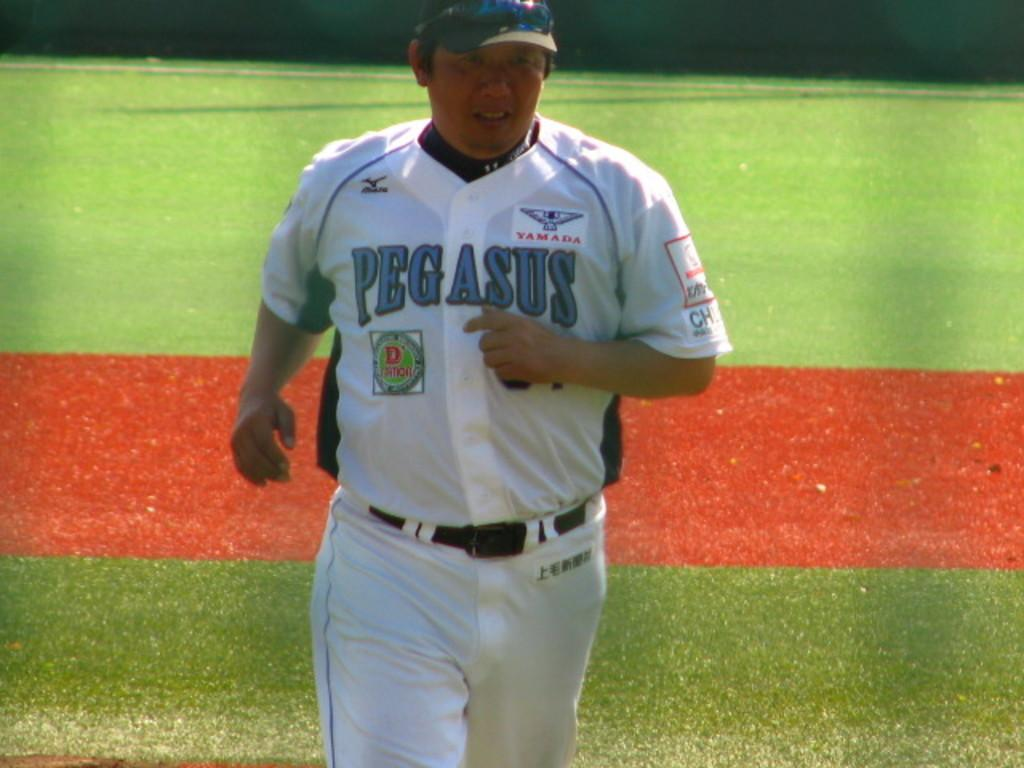<image>
Share a concise interpretation of the image provided. A baseball player is running across the field and his uniform says Pegasus. 